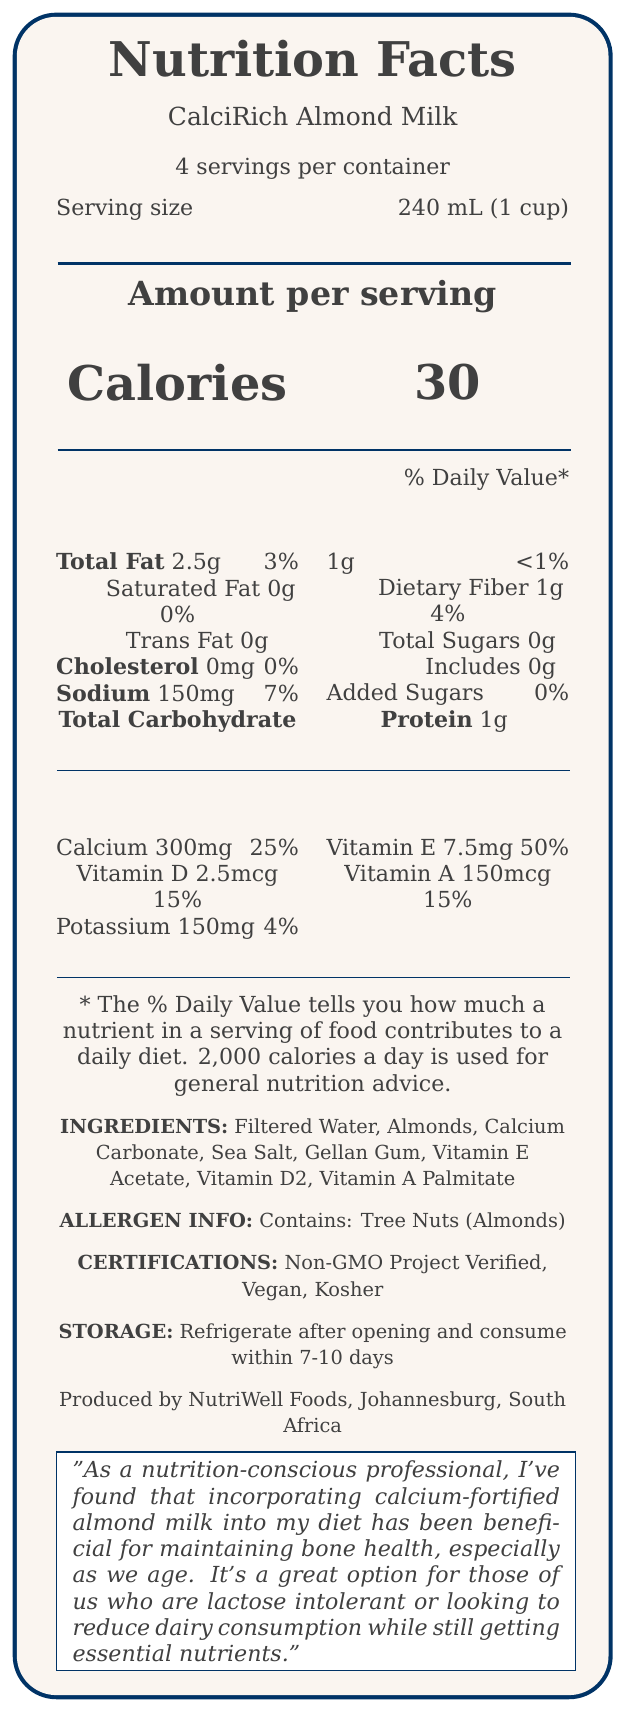what is the serving size? The document clearly states that the serving size is 240 mL (1 cup).
Answer: 240 mL (1 cup) how many calories are in one serving? The calories per serving are mentioned as 30 in the document.
Answer: 30 calories what percentage of the daily value of calcium is in one serving? The document lists calcium as providing 25% of the daily value per serving.
Answer: 25% does this product contain any added sugars? According to the label, there are 0g of added sugars in the product.
Answer: No who is the manufacturer of this product? The document mentions that the product is produced by NutriWell Foods in Johannesburg, South Africa.
Answer: NutriWell Foods, Johannesburg, South Africa how many servings are there per container? The document states there are 4 servings per container.
Answer: 4 what vitamins are included in this product? A. Vitamin C B. Vitamin D C. Vitamin B6 D. Vitamin E The document lists vitamin D and vitamin E as being included in the product.
Answer: B and D which of the following nutrients has the highest percentage of daily value in this product? I. Calcium II. Sodium III. Vitamin E IV. Potassium The document indicates Vitamin E has 50% of the daily value per serving, which is higher than others listed.
Answer: III. Vitamin E is this product dairy-free? Yes/No The document states this is a non-dairy milk alternative, making it dairy-free.
Answer: Yes summarize the main idea of this document. The document broadly summarizes the nutritional content, ingredients, allergen information, certifications, and storage instructions of CalciRich Almond Milk, highlighting its benefits for those who are lactose intolerant or reducing dairy intake.
Answer: The document provides detailed nutritional information about CalciRich Almond Milk, a calcium-fortified, non-dairy milk alternative. It highlights the serving size, calories, fat, cholesterol, sodium, carbohydrates, fiber, sugars, protein, vitamins, and calcium content. The product is vegan, kosher, non-GMO, and produced by NutriWell Foods in Johannesburg, South Africa. It's designed to be a good option for lactose-intolerant individuals or those reducing dairy consumption, offering essential nutrients like calcium and vitamins A, D, and E. how much total fat is in one serving? The document states there are 2.5g of total fat per serving.
Answer: 2.5g contain any artificial flavors and colors? The document does not provide information about whether it contains artificial flavors or colors.
Answer: Not enough information 